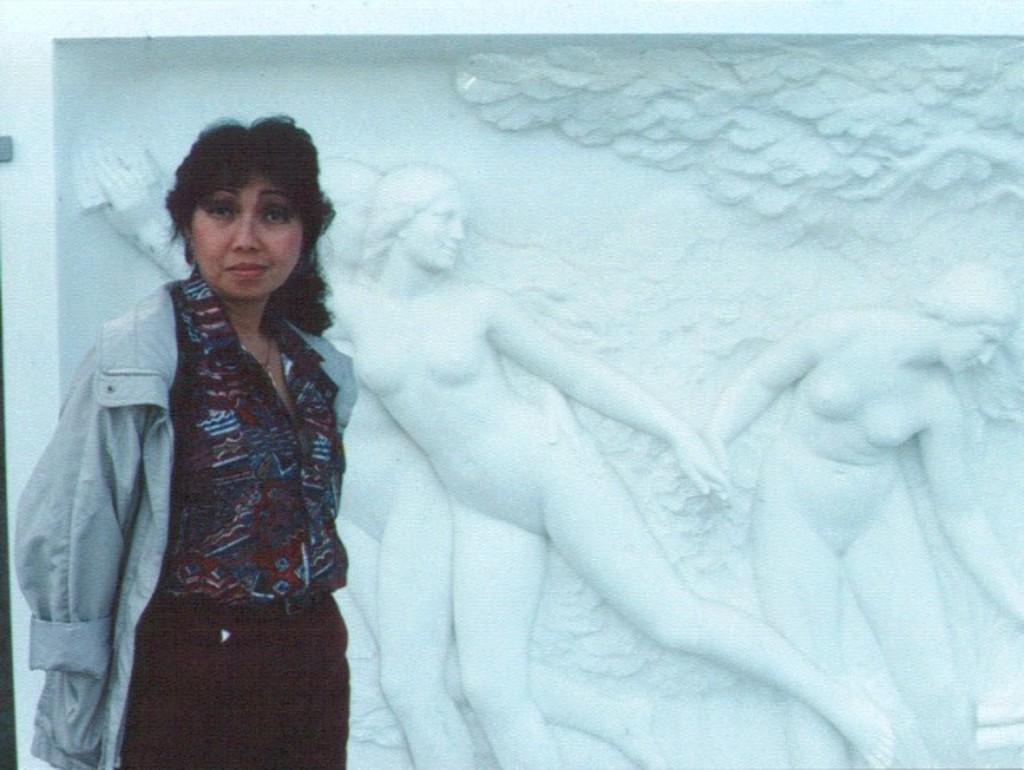What is the main subject of the image? There is a woman standing in the image. Can you describe the background of the image? There are sculptures on the wall in the background of the image. What type of chess piece is depicted in the sculpture on the wall? There is no chess piece visible in the image, as the sculptures on the wall do not depict any chess pieces. How many hens are present in the image? There are no hens present in the image; it features a woman standing and sculptures on the wall. 